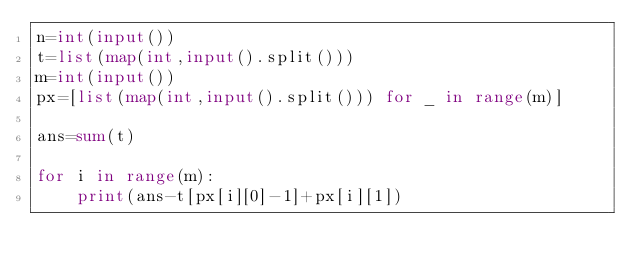Convert code to text. <code><loc_0><loc_0><loc_500><loc_500><_Python_>n=int(input())
t=list(map(int,input().split()))
m=int(input())
px=[list(map(int,input().split())) for _ in range(m)]

ans=sum(t)

for i in range(m):
    print(ans-t[px[i][0]-1]+px[i][1])


</code> 